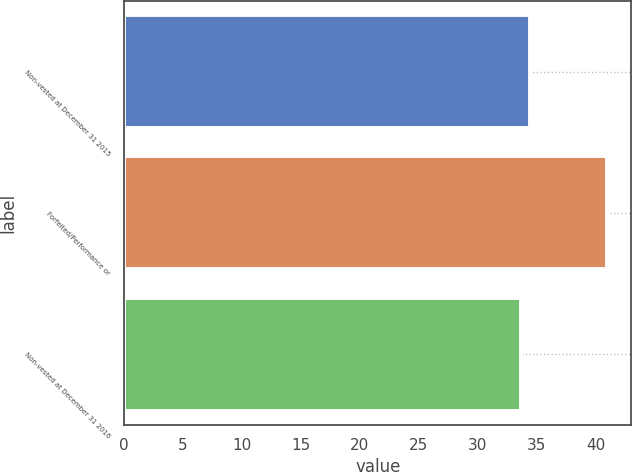<chart> <loc_0><loc_0><loc_500><loc_500><bar_chart><fcel>Non-vested at December 31 2015<fcel>Forfeited/Performance or<fcel>Non-vested at December 31 2016<nl><fcel>34.4<fcel>40.98<fcel>33.67<nl></chart> 